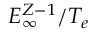Convert formula to latex. <formula><loc_0><loc_0><loc_500><loc_500>E _ { \infty } ^ { Z - 1 } / T _ { e }</formula> 